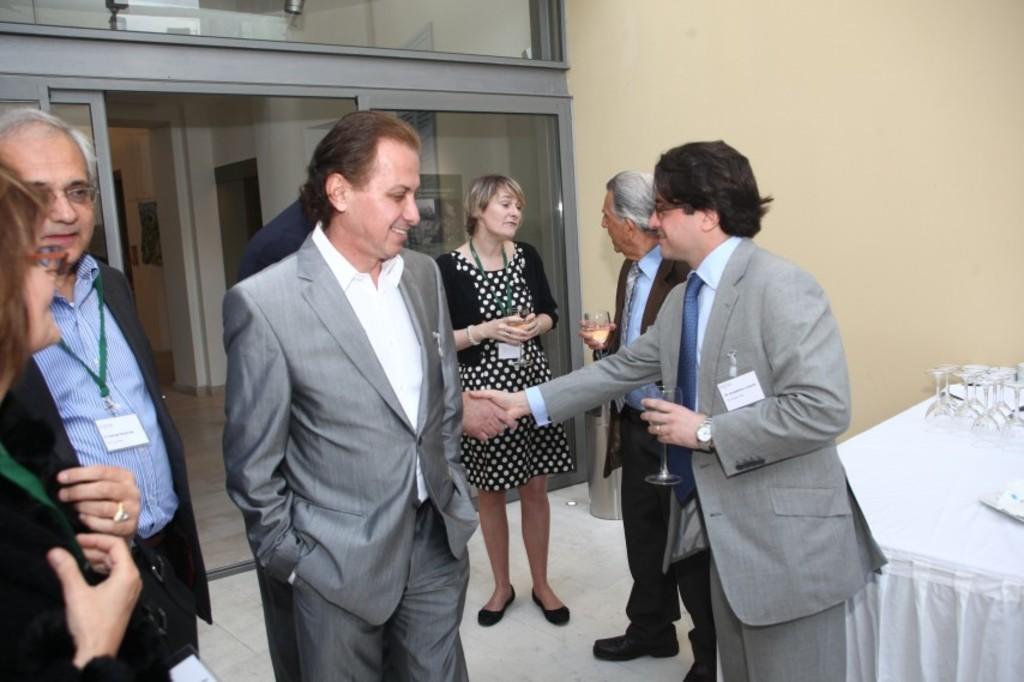How would you summarize this image in a sentence or two? In this image I can see the group of people with different color dresses. I can see few people are holding the glasses. To the right I can see the table. On the table I can see few more glasses. In the background there is a glass door and the wall. 